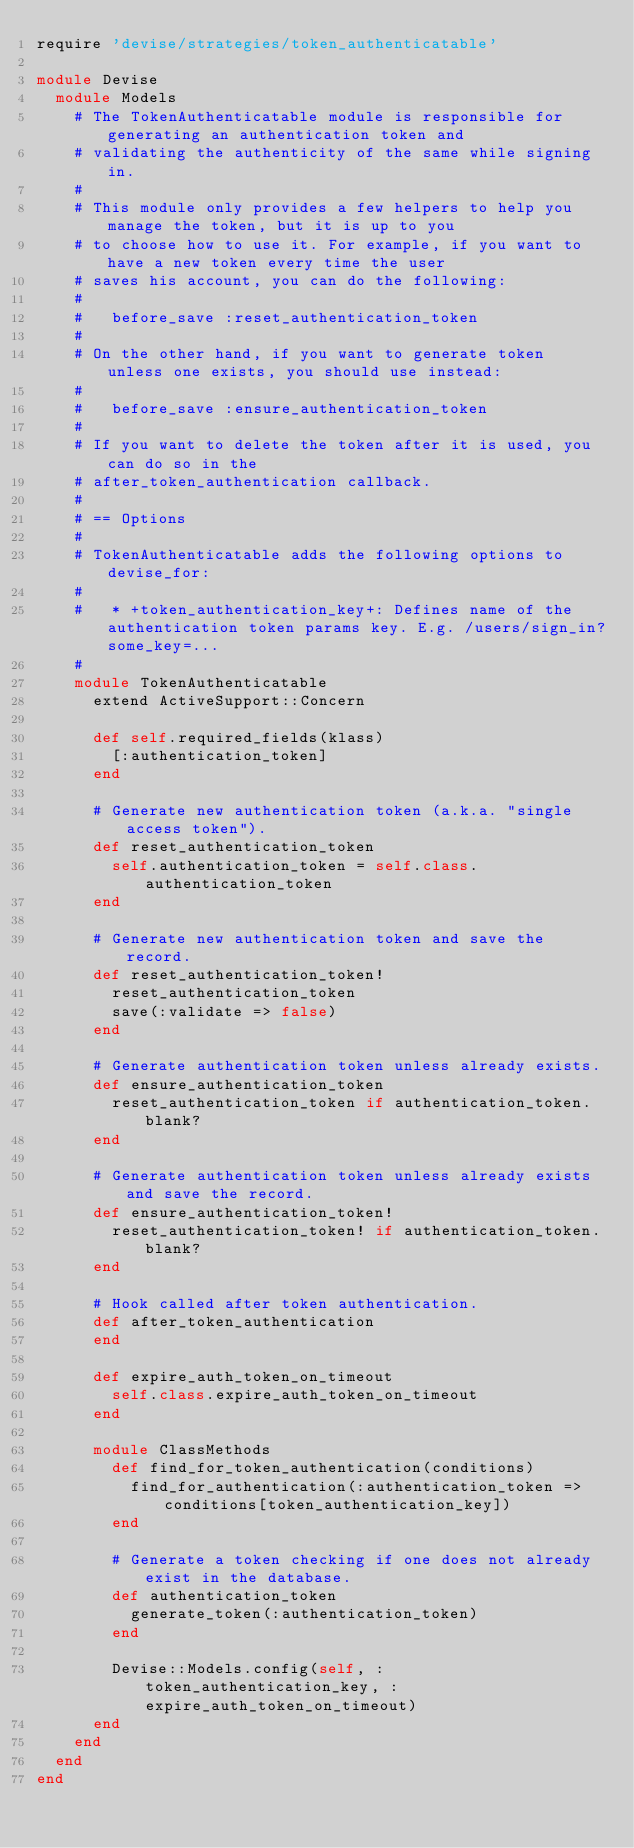Convert code to text. <code><loc_0><loc_0><loc_500><loc_500><_Ruby_>require 'devise/strategies/token_authenticatable'

module Devise
  module Models
    # The TokenAuthenticatable module is responsible for generating an authentication token and
    # validating the authenticity of the same while signing in.
    #
    # This module only provides a few helpers to help you manage the token, but it is up to you
    # to choose how to use it. For example, if you want to have a new token every time the user
    # saves his account, you can do the following:
    #
    #   before_save :reset_authentication_token
    #
    # On the other hand, if you want to generate token unless one exists, you should use instead:
    #
    #   before_save :ensure_authentication_token
    #
    # If you want to delete the token after it is used, you can do so in the
    # after_token_authentication callback.
    #
    # == Options
    #
    # TokenAuthenticatable adds the following options to devise_for:
    #
    #   * +token_authentication_key+: Defines name of the authentication token params key. E.g. /users/sign_in?some_key=...
    #
    module TokenAuthenticatable
      extend ActiveSupport::Concern

      def self.required_fields(klass)
        [:authentication_token]
      end

      # Generate new authentication token (a.k.a. "single access token").
      def reset_authentication_token
        self.authentication_token = self.class.authentication_token
      end

      # Generate new authentication token and save the record.
      def reset_authentication_token!
        reset_authentication_token
        save(:validate => false)
      end

      # Generate authentication token unless already exists.
      def ensure_authentication_token
        reset_authentication_token if authentication_token.blank?
      end

      # Generate authentication token unless already exists and save the record.
      def ensure_authentication_token!
        reset_authentication_token! if authentication_token.blank?
      end

      # Hook called after token authentication.
      def after_token_authentication
      end

      def expire_auth_token_on_timeout
        self.class.expire_auth_token_on_timeout
      end

      module ClassMethods
        def find_for_token_authentication(conditions)
          find_for_authentication(:authentication_token => conditions[token_authentication_key])
        end

        # Generate a token checking if one does not already exist in the database.
        def authentication_token
          generate_token(:authentication_token)
        end

        Devise::Models.config(self, :token_authentication_key, :expire_auth_token_on_timeout)
      end
    end
  end
end
</code> 